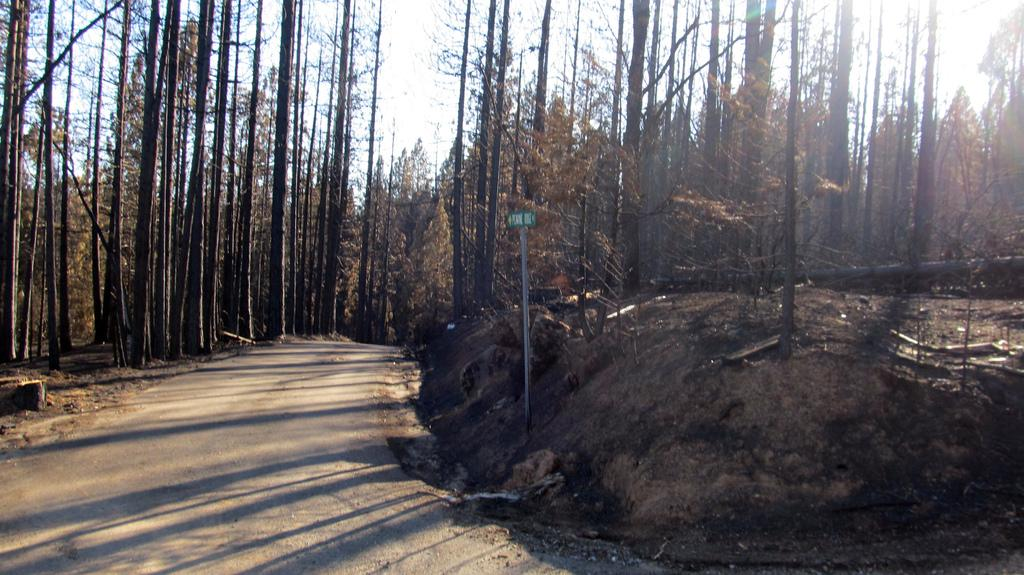What is the main feature of the image? There is a road in the image. What else can be seen in the image besides the road? There is a pole and trees in the image. What is visible in the background of the image? The sky is visible in the background of the image. What type of writer is sitting on the pole in the image? There is no writer present in the image, and the pole is not a place for someone to sit. 